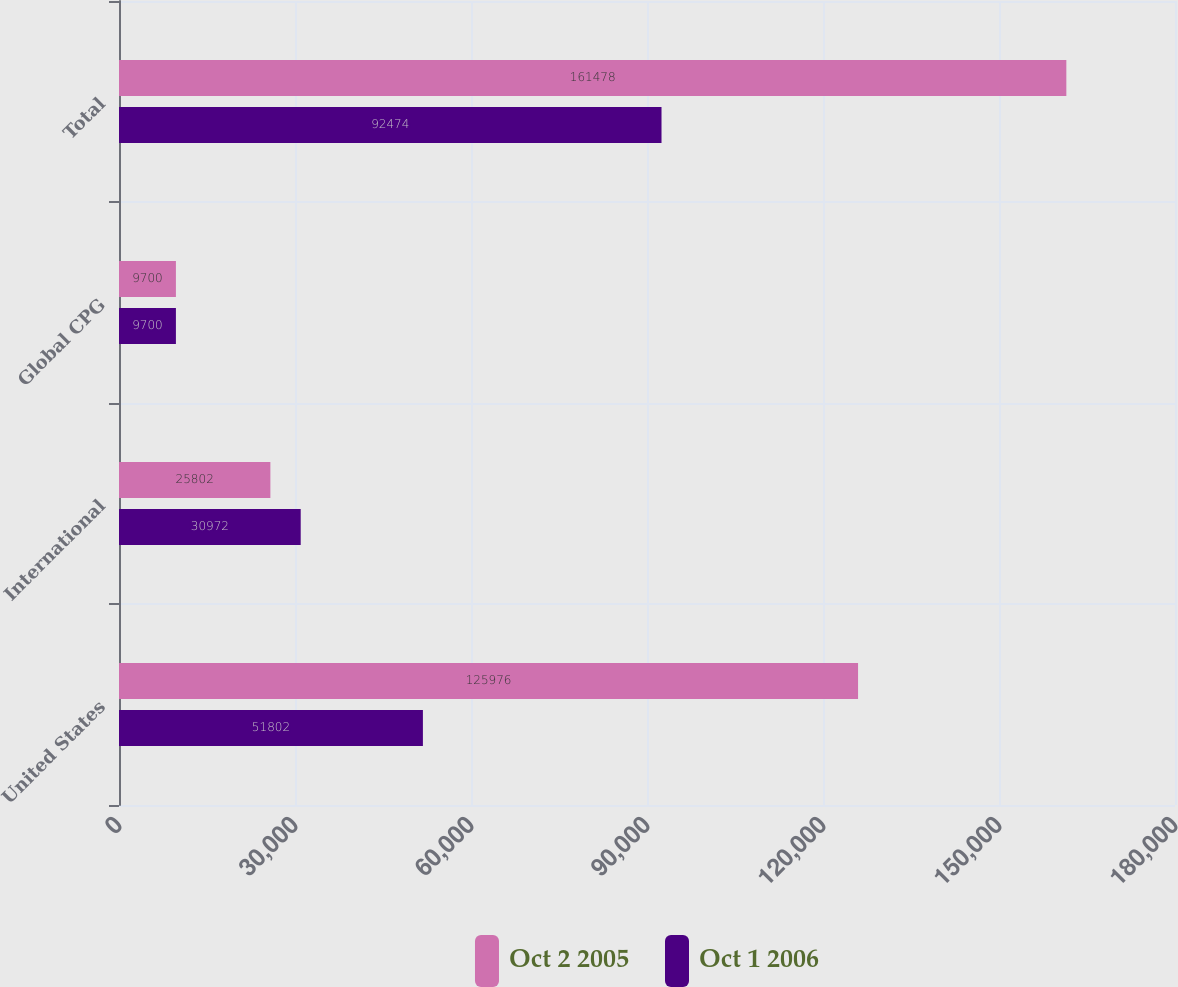<chart> <loc_0><loc_0><loc_500><loc_500><stacked_bar_chart><ecel><fcel>United States<fcel>International<fcel>Global CPG<fcel>Total<nl><fcel>Oct 2 2005<fcel>125976<fcel>25802<fcel>9700<fcel>161478<nl><fcel>Oct 1 2006<fcel>51802<fcel>30972<fcel>9700<fcel>92474<nl></chart> 